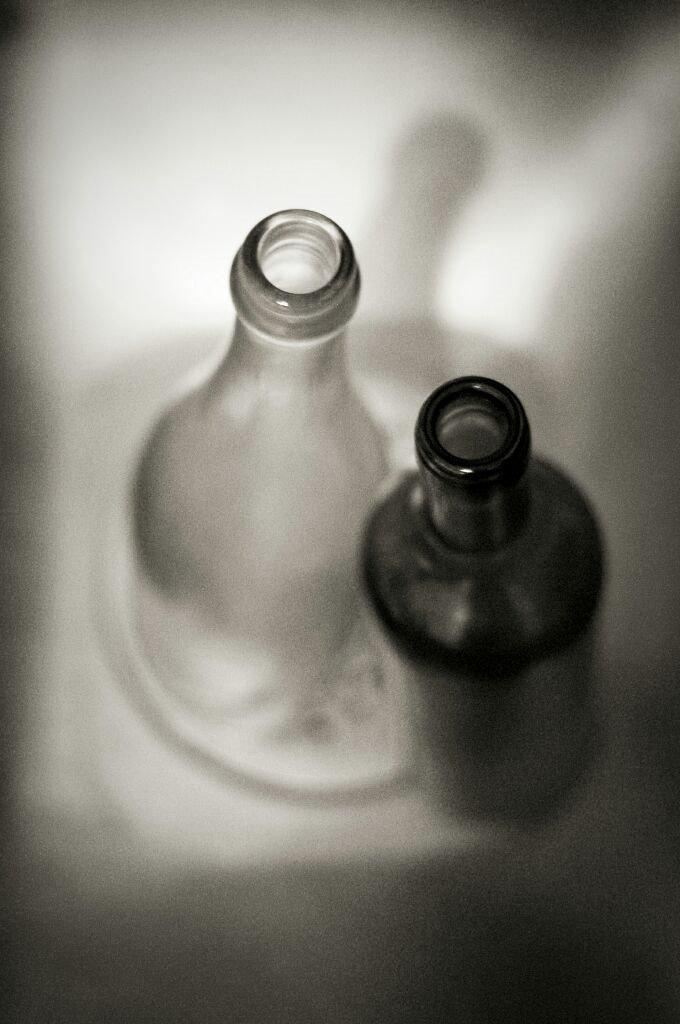How many bottles are visible in the image? There are two bottles in the image. Is there a beggar performing on a stage in the image? There is no mention of a stage, performance, or beggar in the provided fact, so we cannot confirm or deny their presence in the image. 